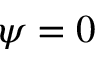Convert formula to latex. <formula><loc_0><loc_0><loc_500><loc_500>\psi = 0</formula> 